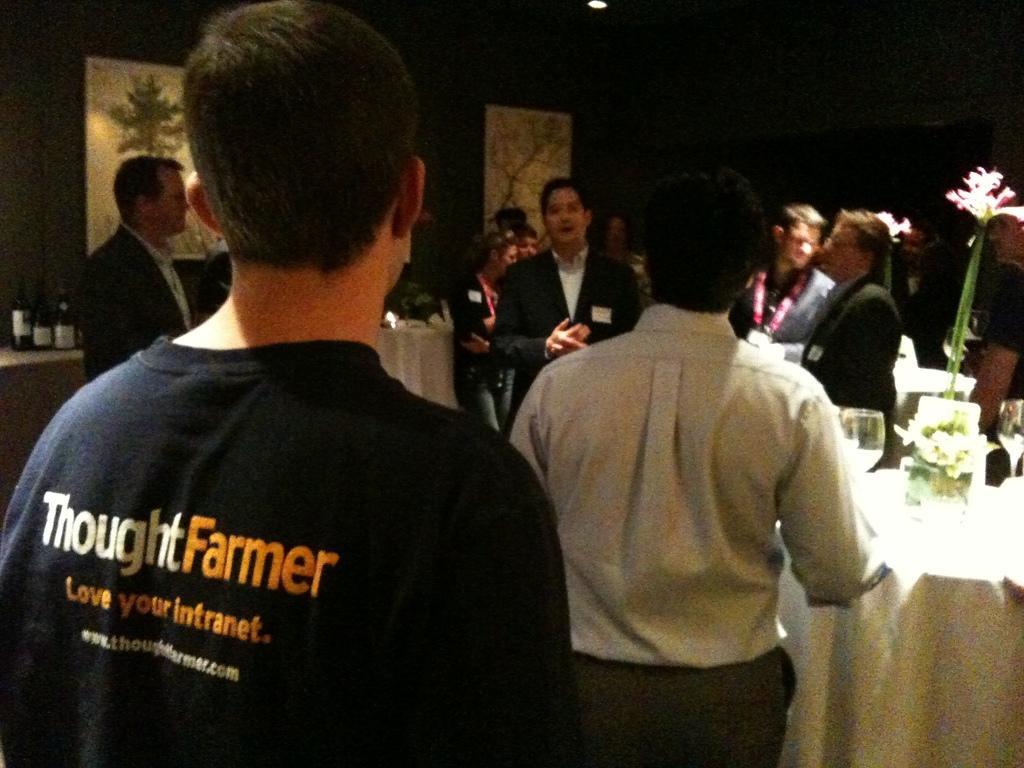Describe this image in one or two sentences. In this image there are a few people standing, in between them there is a table. On the table there are two glasses and a flower vase. On the left side of the image there are a few bottles on the other table. In the background there are few frames are hanging on the wall. 